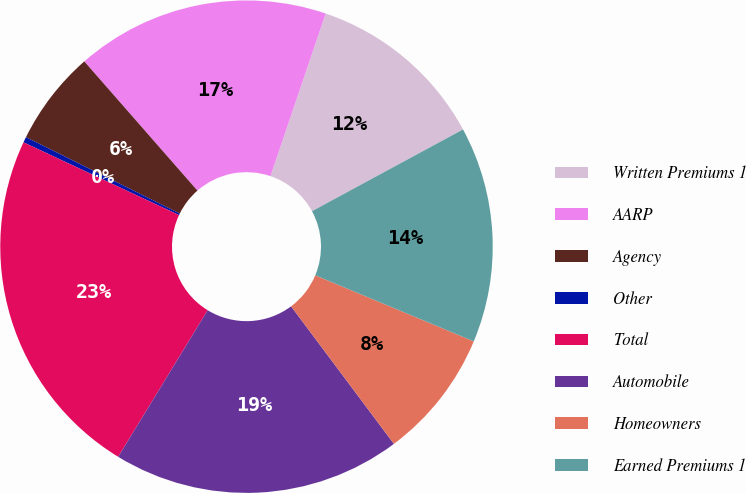Convert chart to OTSL. <chart><loc_0><loc_0><loc_500><loc_500><pie_chart><fcel>Written Premiums 1<fcel>AARP<fcel>Agency<fcel>Other<fcel>Total<fcel>Automobile<fcel>Homeowners<fcel>Earned Premiums 1<nl><fcel>11.89%<fcel>16.66%<fcel>6.22%<fcel>0.37%<fcel>23.24%<fcel>18.94%<fcel>8.5%<fcel>14.18%<nl></chart> 